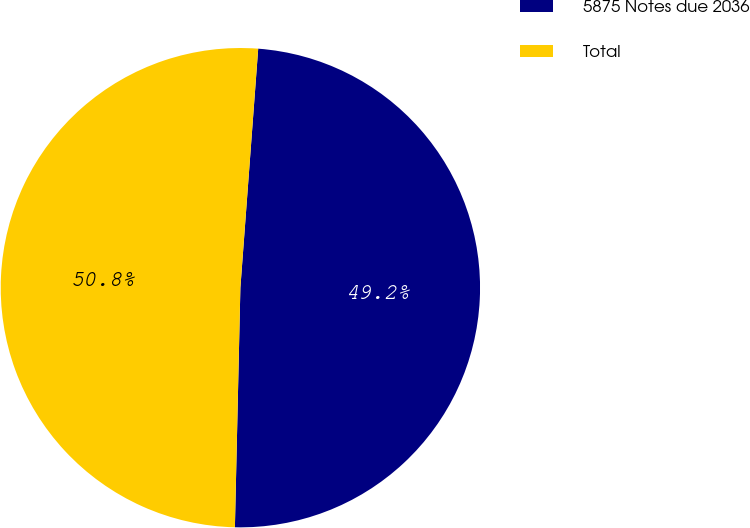<chart> <loc_0><loc_0><loc_500><loc_500><pie_chart><fcel>5875 Notes due 2036<fcel>Total<nl><fcel>49.18%<fcel>50.82%<nl></chart> 